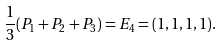<formula> <loc_0><loc_0><loc_500><loc_500>\frac { 1 } { 3 } ( P _ { 1 } + P _ { 2 } + P _ { 3 } ) = E _ { 4 } = ( 1 , 1 , 1 , 1 ) .</formula> 